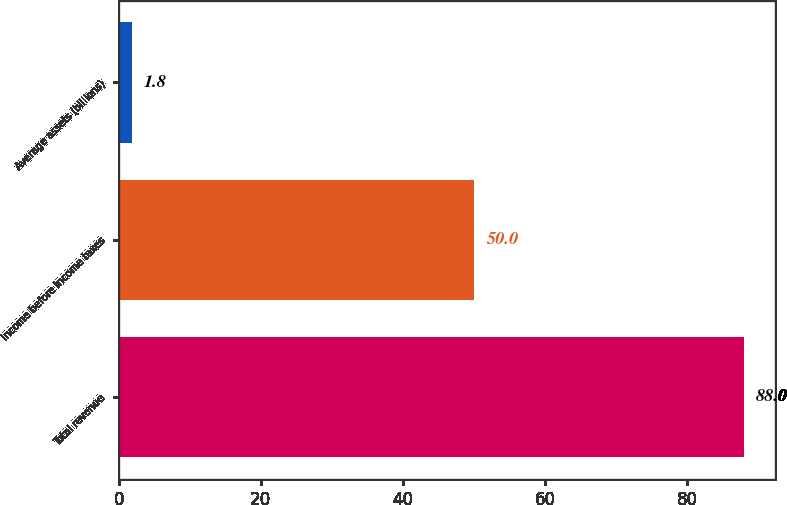Convert chart to OTSL. <chart><loc_0><loc_0><loc_500><loc_500><bar_chart><fcel>Total revenue<fcel>Income before income taxes<fcel>Average assets (billions)<nl><fcel>88<fcel>50<fcel>1.8<nl></chart> 